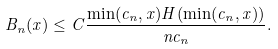<formula> <loc_0><loc_0><loc_500><loc_500>B _ { n } ( x ) \leq C \frac { \min ( c _ { n } , x ) H ( \min ( c _ { n } , x ) ) } { n c _ { n } } .</formula> 